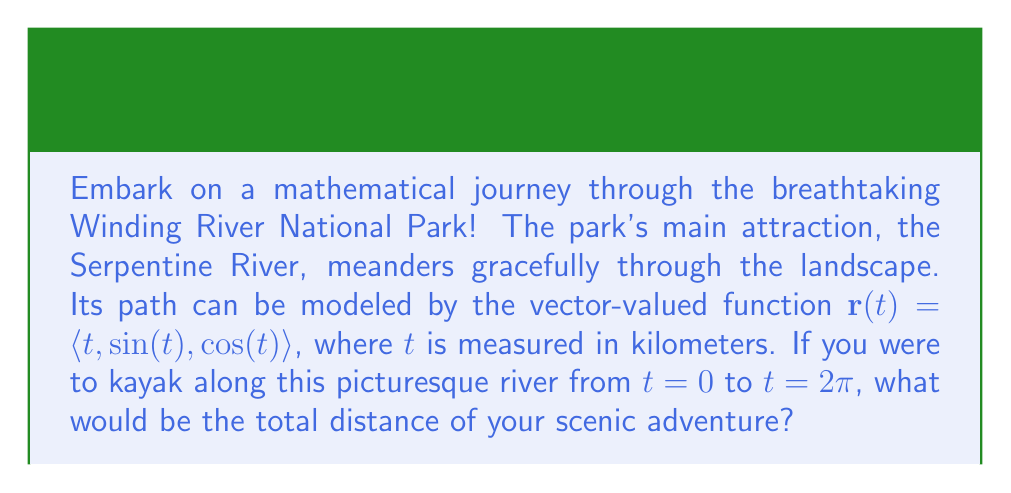Solve this math problem. To find the arc length of the Serpentine River, we need to use the arc length formula for vector-valued functions:

$$L = \int_a^b |\mathbf{r}'(t)| dt$$

where $\mathbf{r}'(t)$ is the derivative of the vector-valued function.

Step 1: Find $\mathbf{r}'(t)$
$$\mathbf{r}'(t) = \langle 1, \cos(t), -\sin(t) \rangle$$

Step 2: Calculate $|\mathbf{r}'(t)|$
$$|\mathbf{r}'(t)| = \sqrt{1^2 + \cos^2(t) + \sin^2(t)}$$
$$|\mathbf{r}'(t)| = \sqrt{1 + \cos^2(t) + \sin^2(t)}$$
$$|\mathbf{r}'(t)| = \sqrt{2}$$ (since $\cos^2(t) + \sin^2(t) = 1$)

Step 3: Set up the integral
$$L = \int_0^{2\pi} \sqrt{2} dt$$

Step 4: Evaluate the integral
$$L = \sqrt{2} \int_0^{2\pi} dt = \sqrt{2} [t]_0^{2\pi} = \sqrt{2} (2\pi - 0) = 2\pi\sqrt{2}$$

Therefore, the total distance of your kayaking adventure along the Serpentine River is $2\pi\sqrt{2}$ kilometers.
Answer: $2\pi\sqrt{2}$ kilometers 